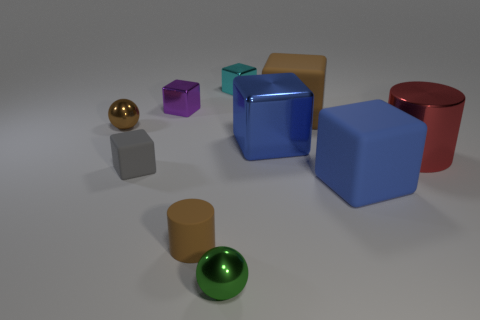What number of spheres are small gray rubber objects or small purple metal things?
Ensure brevity in your answer.  0. There is a tiny object that is the same color as the tiny cylinder; what is it made of?
Keep it short and to the point. Metal. There is a blue thing to the left of the large brown object; is it the same shape as the brown matte thing right of the tiny green shiny thing?
Your response must be concise. Yes. There is a matte block that is right of the tiny brown cylinder and in front of the brown ball; what color is it?
Provide a short and direct response. Blue. Does the big metal cube have the same color as the big matte block that is in front of the blue metallic cube?
Offer a terse response. Yes. There is a rubber object that is to the left of the large blue matte block and on the right side of the green metallic sphere; what size is it?
Offer a very short reply. Large. What number of other objects are the same color as the small matte cylinder?
Keep it short and to the point. 2. There is a brown matte thing that is behind the tiny ball that is behind the ball in front of the large blue metal block; what size is it?
Your answer should be very brief. Large. Are there any cylinders in front of the green ball?
Make the answer very short. No. There is a blue metallic block; does it have the same size as the brown matte thing that is to the right of the blue metallic thing?
Give a very brief answer. Yes. 